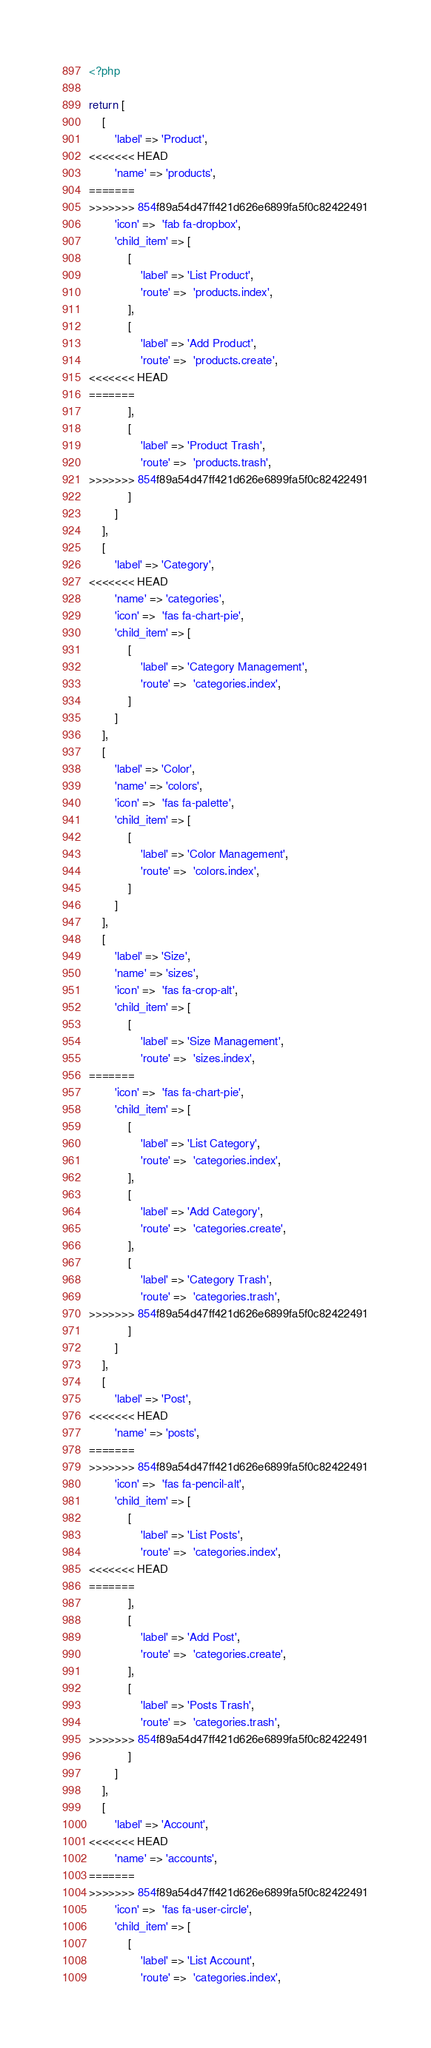Convert code to text. <code><loc_0><loc_0><loc_500><loc_500><_PHP_><?php

return [
    [
        'label' => 'Product',
<<<<<<< HEAD
        'name' => 'products',
=======
>>>>>>> 854f89a54d47ff421d626e6899fa5f0c82422491
        'icon' =>  'fab fa-dropbox',
        'child_item' => [
            [
                'label' => 'List Product',
                'route' =>  'products.index',
            ],
            [
                'label' => 'Add Product',
                'route' =>  'products.create',
<<<<<<< HEAD
=======
            ],
            [
                'label' => 'Product Trash',
                'route' =>  'products.trash',
>>>>>>> 854f89a54d47ff421d626e6899fa5f0c82422491
            ]
        ]
    ],
    [
        'label' => 'Category',
<<<<<<< HEAD
        'name' => 'categories',
        'icon' =>  'fas fa-chart-pie',
        'child_item' => [
            [
                'label' => 'Category Management',
                'route' =>  'categories.index',
            ]
        ]
    ],
    [
        'label' => 'Color',
        'name' => 'colors',
        'icon' =>  'fas fa-palette',
        'child_item' => [
            [
                'label' => 'Color Management',
                'route' =>  'colors.index',
            ]
        ]
    ],
    [
        'label' => 'Size',
        'name' => 'sizes',
        'icon' =>  'fas fa-crop-alt',
        'child_item' => [
            [
                'label' => 'Size Management',
                'route' =>  'sizes.index',
=======
        'icon' =>  'fas fa-chart-pie',
        'child_item' => [
            [
                'label' => 'List Category',
                'route' =>  'categories.index',
            ],
            [
                'label' => 'Add Category',
                'route' =>  'categories.create',
            ],
            [
                'label' => 'Category Trash',
                'route' =>  'categories.trash',
>>>>>>> 854f89a54d47ff421d626e6899fa5f0c82422491
            ]
        ]
    ],
    [
        'label' => 'Post',
<<<<<<< HEAD
        'name' => 'posts',
=======
>>>>>>> 854f89a54d47ff421d626e6899fa5f0c82422491
        'icon' =>  'fas fa-pencil-alt',
        'child_item' => [
            [
                'label' => 'List Posts',
                'route' =>  'categories.index',
<<<<<<< HEAD
=======
            ],
            [
                'label' => 'Add Post',
                'route' =>  'categories.create',
            ],
            [
                'label' => 'Posts Trash',
                'route' =>  'categories.trash',
>>>>>>> 854f89a54d47ff421d626e6899fa5f0c82422491
            ]
        ]
    ],
    [
        'label' => 'Account',
<<<<<<< HEAD
        'name' => 'accounts',
=======
>>>>>>> 854f89a54d47ff421d626e6899fa5f0c82422491
        'icon' =>  'fas fa-user-circle',
        'child_item' => [
            [
                'label' => 'List Account',
                'route' =>  'categories.index',</code> 